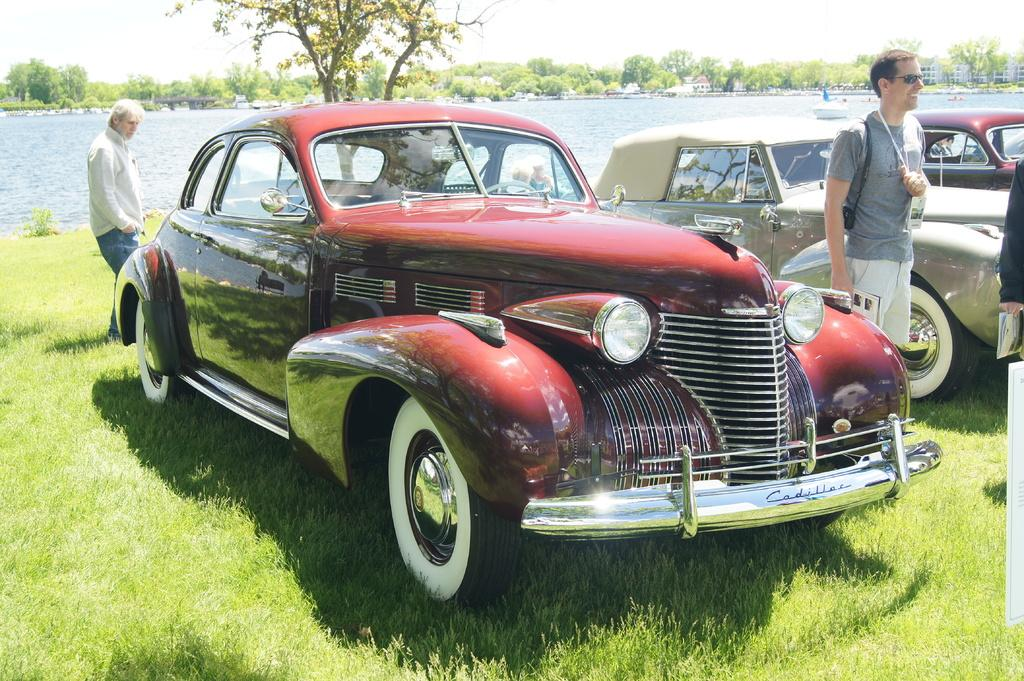Who or what can be seen in the image? There are people in the image. What else is present in the image besides people? There are vehicles and a boat on the water in the image. What can be seen in the background of the image? There are trees and a building in the background of the image. How many dimes are on the boat in the image? There are no dimes present in the image; it features people, vehicles, a boat, trees, and a building. 